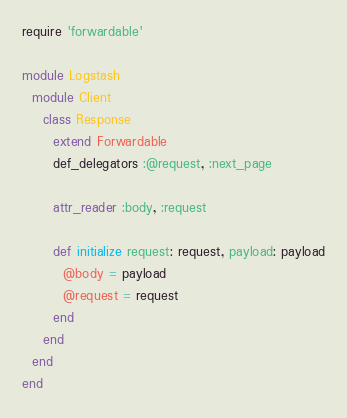<code> <loc_0><loc_0><loc_500><loc_500><_Ruby_>require 'forwardable'

module Logstash
  module Client
    class Response
      extend Forwardable
      def_delegators :@request, :next_page

      attr_reader :body, :request

      def initialize request: request, payload: payload
        @body = payload  
        @request = request
      end
    end
  end
end
</code> 